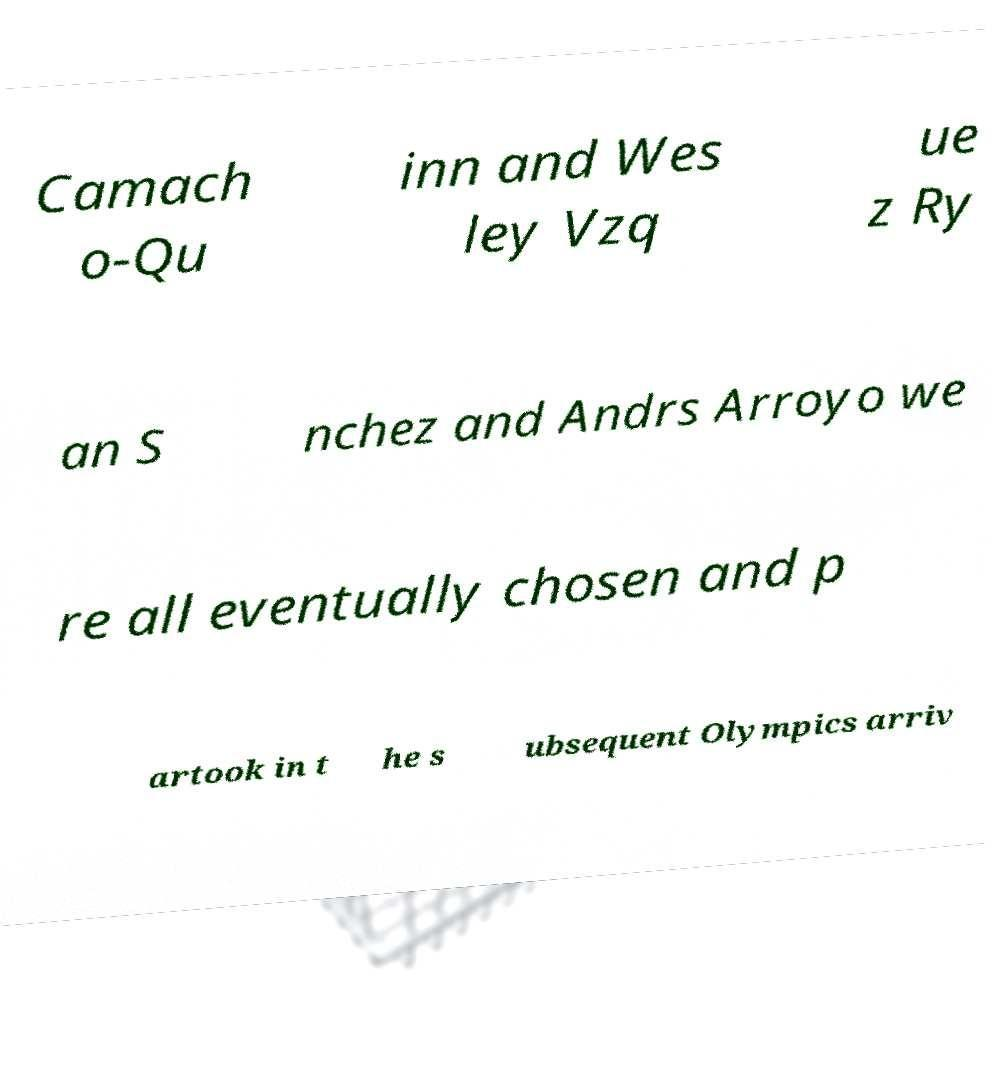For documentation purposes, I need the text within this image transcribed. Could you provide that? Camach o-Qu inn and Wes ley Vzq ue z Ry an S nchez and Andrs Arroyo we re all eventually chosen and p artook in t he s ubsequent Olympics arriv 